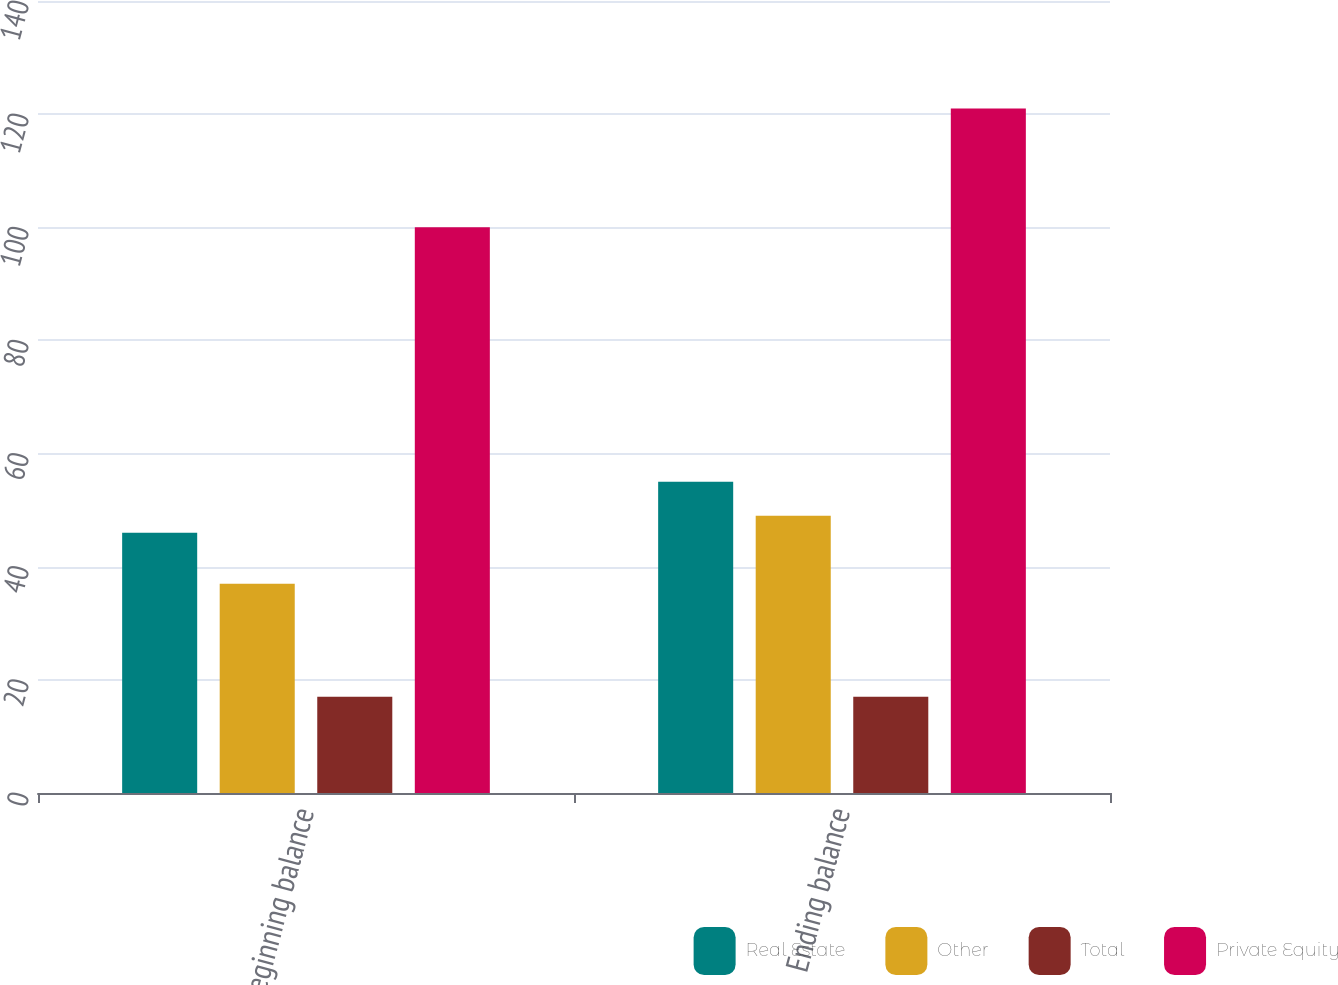<chart> <loc_0><loc_0><loc_500><loc_500><stacked_bar_chart><ecel><fcel>Beginning balance<fcel>Ending balance<nl><fcel>Real Estate<fcel>46<fcel>55<nl><fcel>Other<fcel>37<fcel>49<nl><fcel>Total<fcel>17<fcel>17<nl><fcel>Private Equity<fcel>100<fcel>121<nl></chart> 